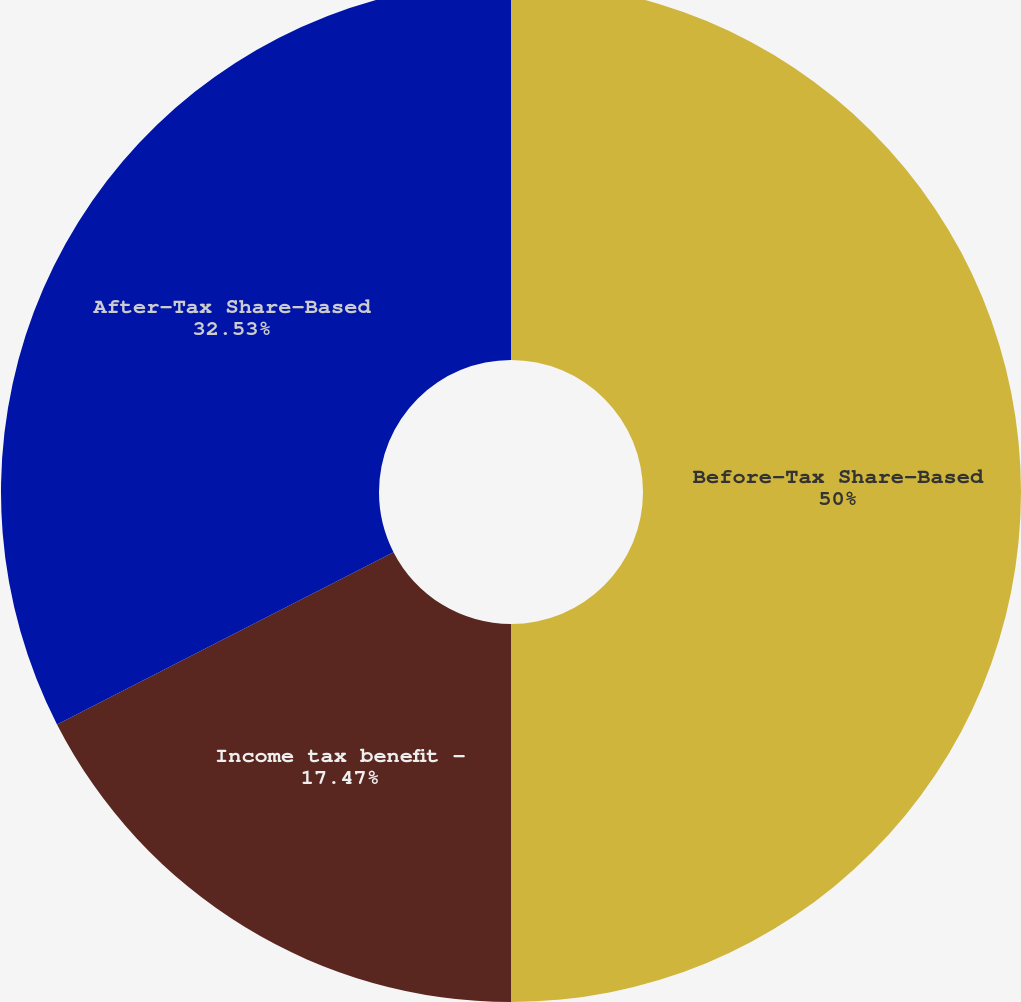<chart> <loc_0><loc_0><loc_500><loc_500><pie_chart><fcel>Before-Tax Share-Based<fcel>Income tax benefit -<fcel>After-Tax Share-Based<nl><fcel>50.0%<fcel>17.47%<fcel>32.53%<nl></chart> 